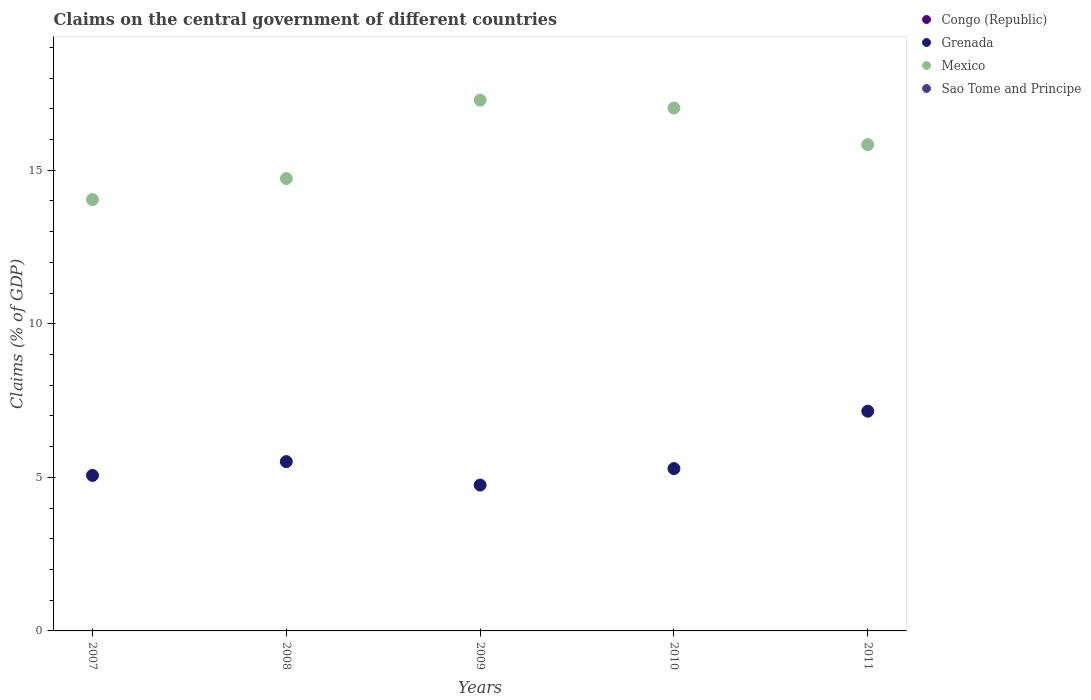How many different coloured dotlines are there?
Provide a short and direct response. 2. Is the number of dotlines equal to the number of legend labels?
Your answer should be very brief. No. What is the percentage of GDP claimed on the central government in Grenada in 2011?
Ensure brevity in your answer.  7.15. Across all years, what is the maximum percentage of GDP claimed on the central government in Grenada?
Your response must be concise. 7.15. Across all years, what is the minimum percentage of GDP claimed on the central government in Congo (Republic)?
Make the answer very short. 0. In which year was the percentage of GDP claimed on the central government in Grenada maximum?
Offer a very short reply. 2011. What is the total percentage of GDP claimed on the central government in Congo (Republic) in the graph?
Ensure brevity in your answer.  0. What is the difference between the percentage of GDP claimed on the central government in Grenada in 2007 and that in 2011?
Keep it short and to the point. -2.09. What is the difference between the percentage of GDP claimed on the central government in Congo (Republic) in 2008 and the percentage of GDP claimed on the central government in Mexico in 2010?
Keep it short and to the point. -17.02. What is the average percentage of GDP claimed on the central government in Grenada per year?
Your answer should be compact. 5.55. In the year 2009, what is the difference between the percentage of GDP claimed on the central government in Mexico and percentage of GDP claimed on the central government in Grenada?
Ensure brevity in your answer.  12.53. What is the ratio of the percentage of GDP claimed on the central government in Mexico in 2008 to that in 2009?
Provide a short and direct response. 0.85. Is the percentage of GDP claimed on the central government in Grenada in 2009 less than that in 2011?
Your response must be concise. Yes. Is the difference between the percentage of GDP claimed on the central government in Mexico in 2007 and 2011 greater than the difference between the percentage of GDP claimed on the central government in Grenada in 2007 and 2011?
Your answer should be compact. Yes. What is the difference between the highest and the second highest percentage of GDP claimed on the central government in Mexico?
Provide a succinct answer. 0.26. What is the difference between the highest and the lowest percentage of GDP claimed on the central government in Grenada?
Offer a very short reply. 2.4. Does the percentage of GDP claimed on the central government in Grenada monotonically increase over the years?
Provide a succinct answer. No. Is the percentage of GDP claimed on the central government in Congo (Republic) strictly greater than the percentage of GDP claimed on the central government in Sao Tome and Principe over the years?
Provide a short and direct response. No. How many dotlines are there?
Make the answer very short. 2. Where does the legend appear in the graph?
Your answer should be compact. Top right. How many legend labels are there?
Ensure brevity in your answer.  4. What is the title of the graph?
Ensure brevity in your answer.  Claims on the central government of different countries. Does "Uzbekistan" appear as one of the legend labels in the graph?
Your answer should be compact. No. What is the label or title of the Y-axis?
Your answer should be compact. Claims (% of GDP). What is the Claims (% of GDP) of Congo (Republic) in 2007?
Offer a very short reply. 0. What is the Claims (% of GDP) in Grenada in 2007?
Ensure brevity in your answer.  5.06. What is the Claims (% of GDP) of Mexico in 2007?
Your answer should be compact. 14.04. What is the Claims (% of GDP) in Congo (Republic) in 2008?
Your answer should be compact. 0. What is the Claims (% of GDP) of Grenada in 2008?
Ensure brevity in your answer.  5.51. What is the Claims (% of GDP) in Mexico in 2008?
Offer a very short reply. 14.73. What is the Claims (% of GDP) of Sao Tome and Principe in 2008?
Your response must be concise. 0. What is the Claims (% of GDP) in Grenada in 2009?
Your answer should be compact. 4.75. What is the Claims (% of GDP) in Mexico in 2009?
Keep it short and to the point. 17.28. What is the Claims (% of GDP) in Sao Tome and Principe in 2009?
Your response must be concise. 0. What is the Claims (% of GDP) in Congo (Republic) in 2010?
Your answer should be compact. 0. What is the Claims (% of GDP) of Grenada in 2010?
Your response must be concise. 5.28. What is the Claims (% of GDP) of Mexico in 2010?
Your answer should be compact. 17.02. What is the Claims (% of GDP) in Congo (Republic) in 2011?
Your answer should be compact. 0. What is the Claims (% of GDP) in Grenada in 2011?
Your response must be concise. 7.15. What is the Claims (% of GDP) in Mexico in 2011?
Provide a short and direct response. 15.83. What is the Claims (% of GDP) in Sao Tome and Principe in 2011?
Provide a short and direct response. 0. Across all years, what is the maximum Claims (% of GDP) in Grenada?
Offer a terse response. 7.15. Across all years, what is the maximum Claims (% of GDP) in Mexico?
Ensure brevity in your answer.  17.28. Across all years, what is the minimum Claims (% of GDP) in Grenada?
Ensure brevity in your answer.  4.75. Across all years, what is the minimum Claims (% of GDP) of Mexico?
Ensure brevity in your answer.  14.04. What is the total Claims (% of GDP) in Congo (Republic) in the graph?
Make the answer very short. 0. What is the total Claims (% of GDP) in Grenada in the graph?
Keep it short and to the point. 27.76. What is the total Claims (% of GDP) of Mexico in the graph?
Your answer should be compact. 78.91. What is the difference between the Claims (% of GDP) in Grenada in 2007 and that in 2008?
Your answer should be compact. -0.45. What is the difference between the Claims (% of GDP) of Mexico in 2007 and that in 2008?
Provide a succinct answer. -0.68. What is the difference between the Claims (% of GDP) of Grenada in 2007 and that in 2009?
Your response must be concise. 0.31. What is the difference between the Claims (% of GDP) of Mexico in 2007 and that in 2009?
Your answer should be very brief. -3.24. What is the difference between the Claims (% of GDP) of Grenada in 2007 and that in 2010?
Offer a very short reply. -0.22. What is the difference between the Claims (% of GDP) of Mexico in 2007 and that in 2010?
Give a very brief answer. -2.98. What is the difference between the Claims (% of GDP) of Grenada in 2007 and that in 2011?
Provide a succinct answer. -2.09. What is the difference between the Claims (% of GDP) of Mexico in 2007 and that in 2011?
Keep it short and to the point. -1.79. What is the difference between the Claims (% of GDP) of Grenada in 2008 and that in 2009?
Make the answer very short. 0.76. What is the difference between the Claims (% of GDP) in Mexico in 2008 and that in 2009?
Give a very brief answer. -2.55. What is the difference between the Claims (% of GDP) in Grenada in 2008 and that in 2010?
Your answer should be compact. 0.23. What is the difference between the Claims (% of GDP) in Mexico in 2008 and that in 2010?
Provide a short and direct response. -2.29. What is the difference between the Claims (% of GDP) of Grenada in 2008 and that in 2011?
Give a very brief answer. -1.64. What is the difference between the Claims (% of GDP) in Mexico in 2008 and that in 2011?
Your response must be concise. -1.11. What is the difference between the Claims (% of GDP) in Grenada in 2009 and that in 2010?
Give a very brief answer. -0.54. What is the difference between the Claims (% of GDP) in Mexico in 2009 and that in 2010?
Provide a succinct answer. 0.26. What is the difference between the Claims (% of GDP) of Grenada in 2009 and that in 2011?
Give a very brief answer. -2.4. What is the difference between the Claims (% of GDP) of Mexico in 2009 and that in 2011?
Give a very brief answer. 1.45. What is the difference between the Claims (% of GDP) of Grenada in 2010 and that in 2011?
Give a very brief answer. -1.87. What is the difference between the Claims (% of GDP) in Mexico in 2010 and that in 2011?
Your answer should be very brief. 1.19. What is the difference between the Claims (% of GDP) in Grenada in 2007 and the Claims (% of GDP) in Mexico in 2008?
Offer a terse response. -9.67. What is the difference between the Claims (% of GDP) of Grenada in 2007 and the Claims (% of GDP) of Mexico in 2009?
Provide a succinct answer. -12.22. What is the difference between the Claims (% of GDP) of Grenada in 2007 and the Claims (% of GDP) of Mexico in 2010?
Ensure brevity in your answer.  -11.96. What is the difference between the Claims (% of GDP) in Grenada in 2007 and the Claims (% of GDP) in Mexico in 2011?
Ensure brevity in your answer.  -10.77. What is the difference between the Claims (% of GDP) in Grenada in 2008 and the Claims (% of GDP) in Mexico in 2009?
Provide a succinct answer. -11.77. What is the difference between the Claims (% of GDP) in Grenada in 2008 and the Claims (% of GDP) in Mexico in 2010?
Keep it short and to the point. -11.51. What is the difference between the Claims (% of GDP) in Grenada in 2008 and the Claims (% of GDP) in Mexico in 2011?
Provide a succinct answer. -10.32. What is the difference between the Claims (% of GDP) of Grenada in 2009 and the Claims (% of GDP) of Mexico in 2010?
Your answer should be very brief. -12.27. What is the difference between the Claims (% of GDP) in Grenada in 2009 and the Claims (% of GDP) in Mexico in 2011?
Provide a short and direct response. -11.08. What is the difference between the Claims (% of GDP) of Grenada in 2010 and the Claims (% of GDP) of Mexico in 2011?
Provide a short and direct response. -10.55. What is the average Claims (% of GDP) in Congo (Republic) per year?
Make the answer very short. 0. What is the average Claims (% of GDP) of Grenada per year?
Make the answer very short. 5.55. What is the average Claims (% of GDP) in Mexico per year?
Keep it short and to the point. 15.78. In the year 2007, what is the difference between the Claims (% of GDP) of Grenada and Claims (% of GDP) of Mexico?
Offer a very short reply. -8.98. In the year 2008, what is the difference between the Claims (% of GDP) of Grenada and Claims (% of GDP) of Mexico?
Offer a terse response. -9.22. In the year 2009, what is the difference between the Claims (% of GDP) of Grenada and Claims (% of GDP) of Mexico?
Ensure brevity in your answer.  -12.53. In the year 2010, what is the difference between the Claims (% of GDP) of Grenada and Claims (% of GDP) of Mexico?
Provide a succinct answer. -11.74. In the year 2011, what is the difference between the Claims (% of GDP) in Grenada and Claims (% of GDP) in Mexico?
Your response must be concise. -8.68. What is the ratio of the Claims (% of GDP) of Grenada in 2007 to that in 2008?
Keep it short and to the point. 0.92. What is the ratio of the Claims (% of GDP) of Mexico in 2007 to that in 2008?
Make the answer very short. 0.95. What is the ratio of the Claims (% of GDP) in Grenada in 2007 to that in 2009?
Make the answer very short. 1.07. What is the ratio of the Claims (% of GDP) of Mexico in 2007 to that in 2009?
Offer a terse response. 0.81. What is the ratio of the Claims (% of GDP) of Grenada in 2007 to that in 2010?
Offer a very short reply. 0.96. What is the ratio of the Claims (% of GDP) in Mexico in 2007 to that in 2010?
Provide a succinct answer. 0.82. What is the ratio of the Claims (% of GDP) in Grenada in 2007 to that in 2011?
Offer a very short reply. 0.71. What is the ratio of the Claims (% of GDP) of Mexico in 2007 to that in 2011?
Keep it short and to the point. 0.89. What is the ratio of the Claims (% of GDP) of Grenada in 2008 to that in 2009?
Make the answer very short. 1.16. What is the ratio of the Claims (% of GDP) of Mexico in 2008 to that in 2009?
Make the answer very short. 0.85. What is the ratio of the Claims (% of GDP) in Grenada in 2008 to that in 2010?
Your answer should be compact. 1.04. What is the ratio of the Claims (% of GDP) in Mexico in 2008 to that in 2010?
Keep it short and to the point. 0.87. What is the ratio of the Claims (% of GDP) of Grenada in 2008 to that in 2011?
Your response must be concise. 0.77. What is the ratio of the Claims (% of GDP) of Mexico in 2008 to that in 2011?
Keep it short and to the point. 0.93. What is the ratio of the Claims (% of GDP) in Grenada in 2009 to that in 2010?
Make the answer very short. 0.9. What is the ratio of the Claims (% of GDP) of Mexico in 2009 to that in 2010?
Your response must be concise. 1.02. What is the ratio of the Claims (% of GDP) of Grenada in 2009 to that in 2011?
Your answer should be very brief. 0.66. What is the ratio of the Claims (% of GDP) in Mexico in 2009 to that in 2011?
Provide a succinct answer. 1.09. What is the ratio of the Claims (% of GDP) of Grenada in 2010 to that in 2011?
Make the answer very short. 0.74. What is the ratio of the Claims (% of GDP) in Mexico in 2010 to that in 2011?
Provide a short and direct response. 1.08. What is the difference between the highest and the second highest Claims (% of GDP) in Grenada?
Make the answer very short. 1.64. What is the difference between the highest and the second highest Claims (% of GDP) in Mexico?
Provide a succinct answer. 0.26. What is the difference between the highest and the lowest Claims (% of GDP) in Grenada?
Ensure brevity in your answer.  2.4. What is the difference between the highest and the lowest Claims (% of GDP) of Mexico?
Offer a very short reply. 3.24. 